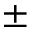Convert formula to latex. <formula><loc_0><loc_0><loc_500><loc_500>\pm</formula> 